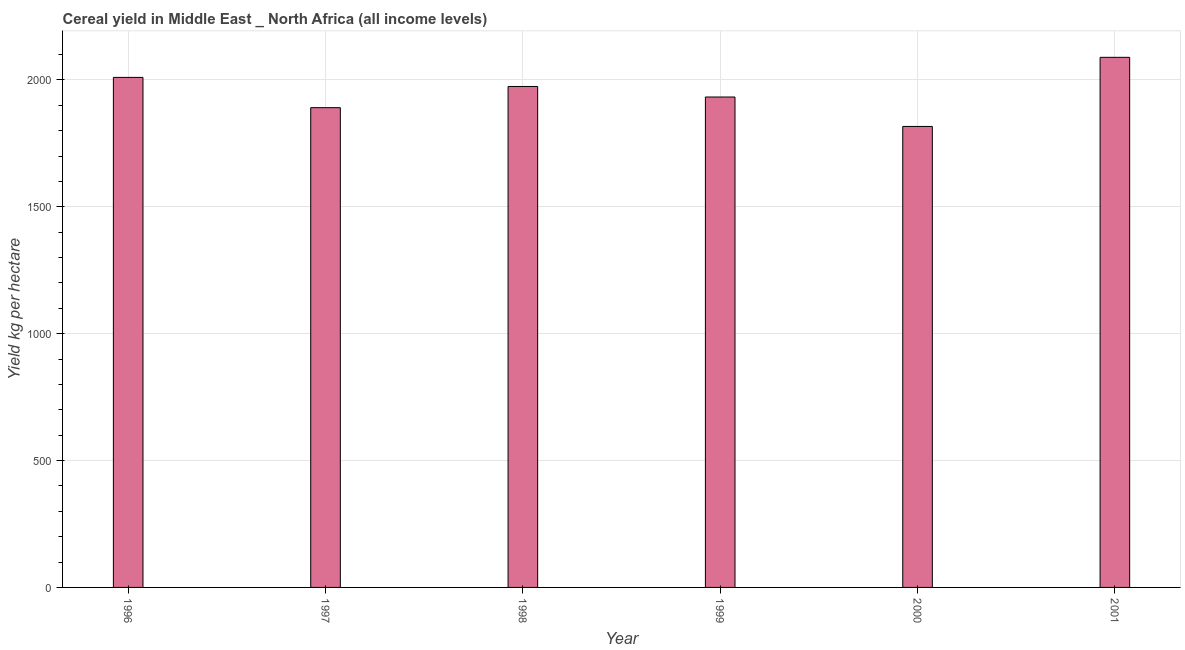Does the graph contain any zero values?
Provide a short and direct response. No. Does the graph contain grids?
Keep it short and to the point. Yes. What is the title of the graph?
Offer a terse response. Cereal yield in Middle East _ North Africa (all income levels). What is the label or title of the X-axis?
Offer a very short reply. Year. What is the label or title of the Y-axis?
Your response must be concise. Yield kg per hectare. What is the cereal yield in 1996?
Your answer should be very brief. 2010.05. Across all years, what is the maximum cereal yield?
Ensure brevity in your answer.  2089.16. Across all years, what is the minimum cereal yield?
Make the answer very short. 1816.74. In which year was the cereal yield minimum?
Keep it short and to the point. 2000. What is the sum of the cereal yield?
Your answer should be compact. 1.17e+04. What is the difference between the cereal yield in 1996 and 1997?
Make the answer very short. 119.28. What is the average cereal yield per year?
Keep it short and to the point. 1952.3. What is the median cereal yield?
Ensure brevity in your answer.  1953.53. What is the ratio of the cereal yield in 1998 to that in 2001?
Give a very brief answer. 0.94. Is the cereal yield in 1999 less than that in 2001?
Provide a short and direct response. Yes. What is the difference between the highest and the second highest cereal yield?
Keep it short and to the point. 79.12. Is the sum of the cereal yield in 1999 and 2000 greater than the maximum cereal yield across all years?
Offer a terse response. Yes. What is the difference between the highest and the lowest cereal yield?
Your answer should be compact. 272.42. In how many years, is the cereal yield greater than the average cereal yield taken over all years?
Your response must be concise. 3. How many years are there in the graph?
Provide a short and direct response. 6. What is the difference between two consecutive major ticks on the Y-axis?
Make the answer very short. 500. Are the values on the major ticks of Y-axis written in scientific E-notation?
Your answer should be compact. No. What is the Yield kg per hectare in 1996?
Your answer should be compact. 2010.05. What is the Yield kg per hectare of 1997?
Make the answer very short. 1890.77. What is the Yield kg per hectare in 1998?
Make the answer very short. 1974.27. What is the Yield kg per hectare in 1999?
Offer a terse response. 1932.79. What is the Yield kg per hectare of 2000?
Keep it short and to the point. 1816.74. What is the Yield kg per hectare of 2001?
Give a very brief answer. 2089.16. What is the difference between the Yield kg per hectare in 1996 and 1997?
Provide a succinct answer. 119.28. What is the difference between the Yield kg per hectare in 1996 and 1998?
Ensure brevity in your answer.  35.77. What is the difference between the Yield kg per hectare in 1996 and 1999?
Your answer should be compact. 77.26. What is the difference between the Yield kg per hectare in 1996 and 2000?
Keep it short and to the point. 193.3. What is the difference between the Yield kg per hectare in 1996 and 2001?
Your response must be concise. -79.12. What is the difference between the Yield kg per hectare in 1997 and 1998?
Make the answer very short. -83.51. What is the difference between the Yield kg per hectare in 1997 and 1999?
Your response must be concise. -42.02. What is the difference between the Yield kg per hectare in 1997 and 2000?
Your answer should be compact. 74.03. What is the difference between the Yield kg per hectare in 1997 and 2001?
Give a very brief answer. -198.39. What is the difference between the Yield kg per hectare in 1998 and 1999?
Your response must be concise. 41.49. What is the difference between the Yield kg per hectare in 1998 and 2000?
Your answer should be very brief. 157.53. What is the difference between the Yield kg per hectare in 1998 and 2001?
Give a very brief answer. -114.89. What is the difference between the Yield kg per hectare in 1999 and 2000?
Make the answer very short. 116.05. What is the difference between the Yield kg per hectare in 1999 and 2001?
Your answer should be very brief. -156.37. What is the difference between the Yield kg per hectare in 2000 and 2001?
Provide a short and direct response. -272.42. What is the ratio of the Yield kg per hectare in 1996 to that in 1997?
Keep it short and to the point. 1.06. What is the ratio of the Yield kg per hectare in 1996 to that in 1998?
Your response must be concise. 1.02. What is the ratio of the Yield kg per hectare in 1996 to that in 1999?
Offer a terse response. 1.04. What is the ratio of the Yield kg per hectare in 1996 to that in 2000?
Your answer should be compact. 1.11. What is the ratio of the Yield kg per hectare in 1997 to that in 1998?
Provide a short and direct response. 0.96. What is the ratio of the Yield kg per hectare in 1997 to that in 1999?
Provide a succinct answer. 0.98. What is the ratio of the Yield kg per hectare in 1997 to that in 2000?
Give a very brief answer. 1.04. What is the ratio of the Yield kg per hectare in 1997 to that in 2001?
Give a very brief answer. 0.91. What is the ratio of the Yield kg per hectare in 1998 to that in 1999?
Your answer should be compact. 1.02. What is the ratio of the Yield kg per hectare in 1998 to that in 2000?
Provide a short and direct response. 1.09. What is the ratio of the Yield kg per hectare in 1998 to that in 2001?
Ensure brevity in your answer.  0.94. What is the ratio of the Yield kg per hectare in 1999 to that in 2000?
Offer a very short reply. 1.06. What is the ratio of the Yield kg per hectare in 1999 to that in 2001?
Give a very brief answer. 0.93. What is the ratio of the Yield kg per hectare in 2000 to that in 2001?
Provide a succinct answer. 0.87. 